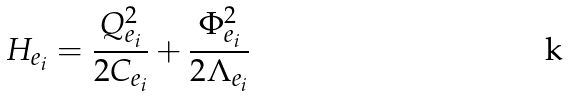<formula> <loc_0><loc_0><loc_500><loc_500>H _ { e _ { i } } = \frac { Q _ { e _ { i } } ^ { 2 } } { 2 C _ { e _ { i } } } + \frac { \Phi _ { e _ { i } } ^ { 2 } } { 2 \Lambda _ { e _ { i } } }</formula> 